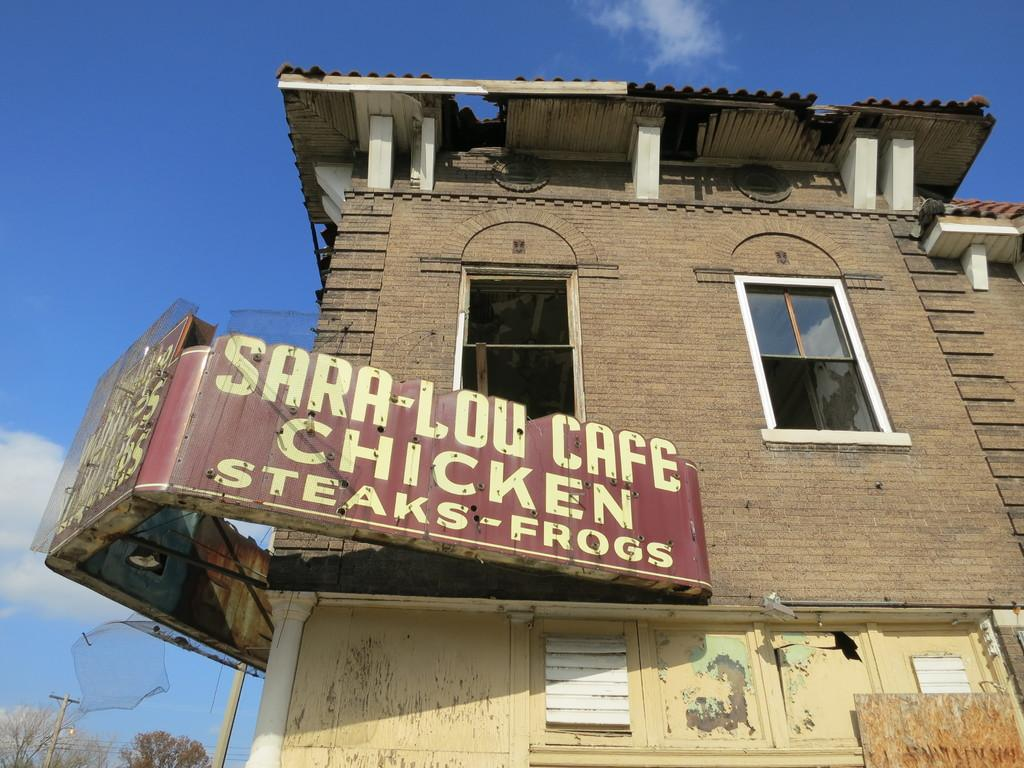What is located in the foreground of the image? There is a board to a building in the foreground of the image. What can be seen in the background of the image? Sky, clouds, a pole, cables, and trees are visible in the background of the image. Can you describe the sky in the image? The sky is visible in the background of the image. What type of vegetation is visible in the background of the image? Trees are visible in the background of the image. What type of desk can be seen in the image? There is no desk present in the image. How does the limit affect the clouds in the image? There is no mention of a limit in the image, and therefore it cannot affect the clouds. 